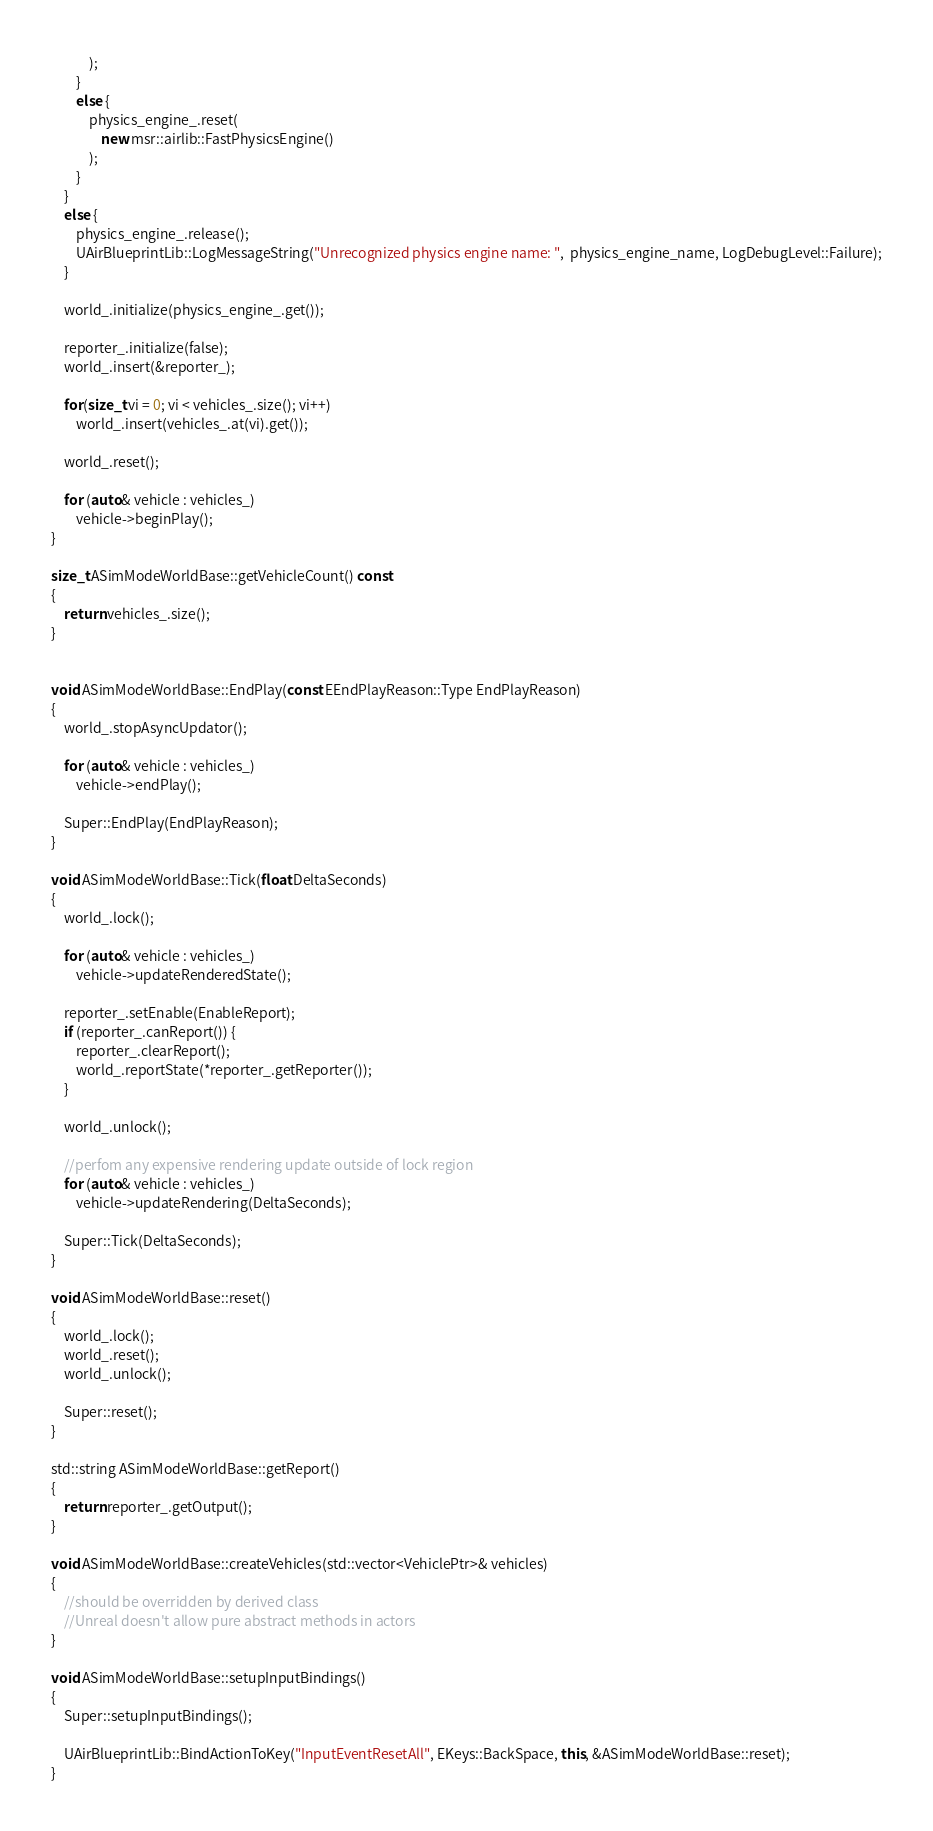<code> <loc_0><loc_0><loc_500><loc_500><_C++_>            );
        }
        else {
            physics_engine_.reset(
                new msr::airlib::FastPhysicsEngine()
            );
        }
    }
    else {
        physics_engine_.release();
        UAirBlueprintLib::LogMessageString("Unrecognized physics engine name: ",  physics_engine_name, LogDebugLevel::Failure);
    }

    world_.initialize(physics_engine_.get());

    reporter_.initialize(false);
    world_.insert(&reporter_);

    for(size_t vi = 0; vi < vehicles_.size(); vi++)
        world_.insert(vehicles_.at(vi).get());

    world_.reset();

    for (auto& vehicle : vehicles_)
        vehicle->beginPlay();
}

size_t ASimModeWorldBase::getVehicleCount() const
{
    return vehicles_.size();
}


void ASimModeWorldBase::EndPlay(const EEndPlayReason::Type EndPlayReason)
{
    world_.stopAsyncUpdator();

    for (auto& vehicle : vehicles_)
        vehicle->endPlay();

    Super::EndPlay(EndPlayReason);
}

void ASimModeWorldBase::Tick(float DeltaSeconds)
{
    world_.lock();

    for (auto& vehicle : vehicles_)
        vehicle->updateRenderedState();

    reporter_.setEnable(EnableReport);
    if (reporter_.canReport()) {
        reporter_.clearReport();
        world_.reportState(*reporter_.getReporter());
    }

    world_.unlock();

    //perfom any expensive rendering update outside of lock region
    for (auto& vehicle : vehicles_)
        vehicle->updateRendering(DeltaSeconds);

    Super::Tick(DeltaSeconds);
}

void ASimModeWorldBase::reset()
{
    world_.lock();
    world_.reset();
    world_.unlock();

    Super::reset();
}

std::string ASimModeWorldBase::getReport()
{
    return reporter_.getOutput();
}

void ASimModeWorldBase::createVehicles(std::vector<VehiclePtr>& vehicles)
{
    //should be overridden by derived class
    //Unreal doesn't allow pure abstract methods in actors
}

void ASimModeWorldBase::setupInputBindings()
{
    Super::setupInputBindings();

    UAirBlueprintLib::BindActionToKey("InputEventResetAll", EKeys::BackSpace, this, &ASimModeWorldBase::reset);
}</code> 